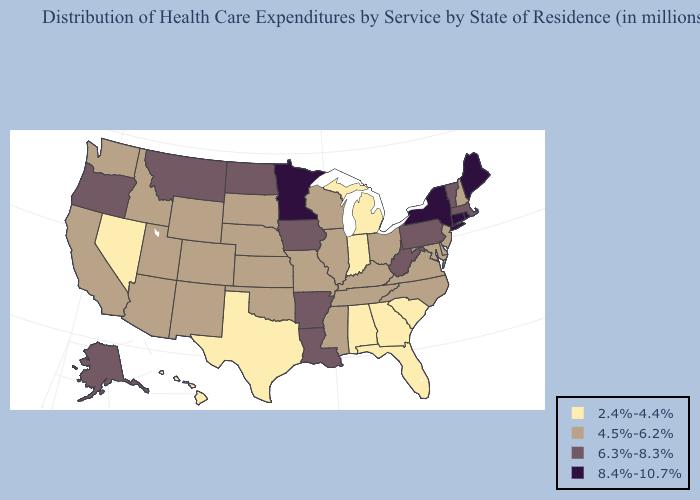Does Idaho have a higher value than Louisiana?
Short answer required. No. Among the states that border Louisiana , does Mississippi have the lowest value?
Answer briefly. No. Name the states that have a value in the range 6.3%-8.3%?
Give a very brief answer. Alaska, Arkansas, Iowa, Louisiana, Massachusetts, Montana, North Dakota, Oregon, Pennsylvania, Vermont, West Virginia. Does the map have missing data?
Be succinct. No. Does Missouri have a lower value than Michigan?
Concise answer only. No. What is the value of New York?
Give a very brief answer. 8.4%-10.7%. Which states have the lowest value in the MidWest?
Keep it brief. Indiana, Michigan. What is the lowest value in the MidWest?
Short answer required. 2.4%-4.4%. Among the states that border Illinois , does Iowa have the highest value?
Keep it brief. Yes. Name the states that have a value in the range 6.3%-8.3%?
Short answer required. Alaska, Arkansas, Iowa, Louisiana, Massachusetts, Montana, North Dakota, Oregon, Pennsylvania, Vermont, West Virginia. Among the states that border New Hampshire , does Maine have the lowest value?
Be succinct. No. Among the states that border Wyoming , does Montana have the lowest value?
Answer briefly. No. How many symbols are there in the legend?
Keep it brief. 4. Does Virginia have the same value as Nebraska?
Keep it brief. Yes. Name the states that have a value in the range 6.3%-8.3%?
Answer briefly. Alaska, Arkansas, Iowa, Louisiana, Massachusetts, Montana, North Dakota, Oregon, Pennsylvania, Vermont, West Virginia. 